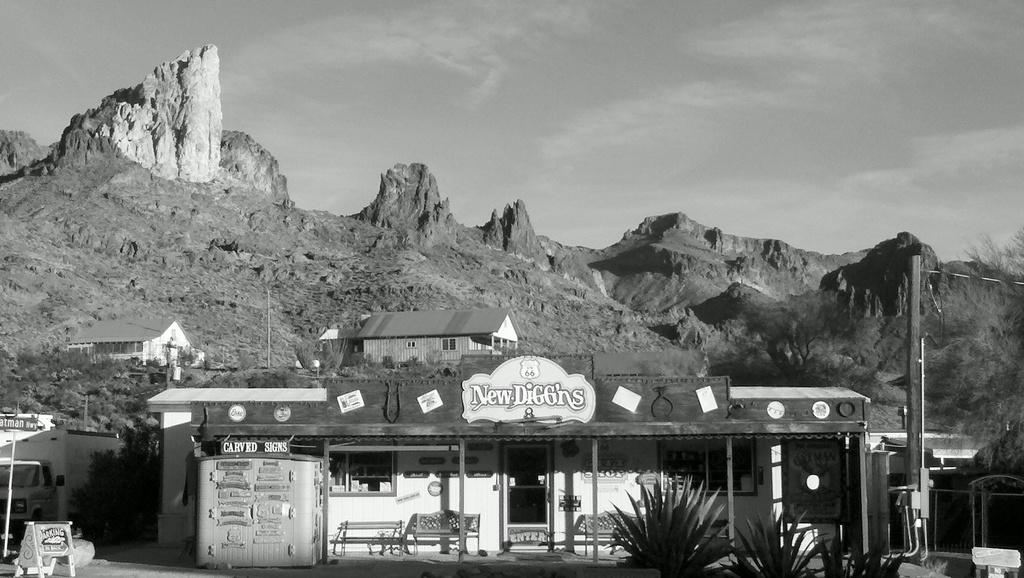What type of structures can be seen in the image? There are houses with windows in the image. What mode of transportation is present in the image? There is a vehicle in the image. What type of seating is available in the image? There are benches in the image. What can be used to enter or exit the houses in the image? There are doors in the image. What type of barrier is present in the image? There is a fence in the image. What type of vegetation is present in the image? There are trees in the image. What type of geographical feature is present in the image? There are mountains in the image. What is visible in the background of the image? The sky with clouds is visible in the background of the image. What type of body of water is present in the image? There is no body of water present in the image. What type of condition is the vehicle in? The condition of the vehicle cannot be determined from the image alone. 